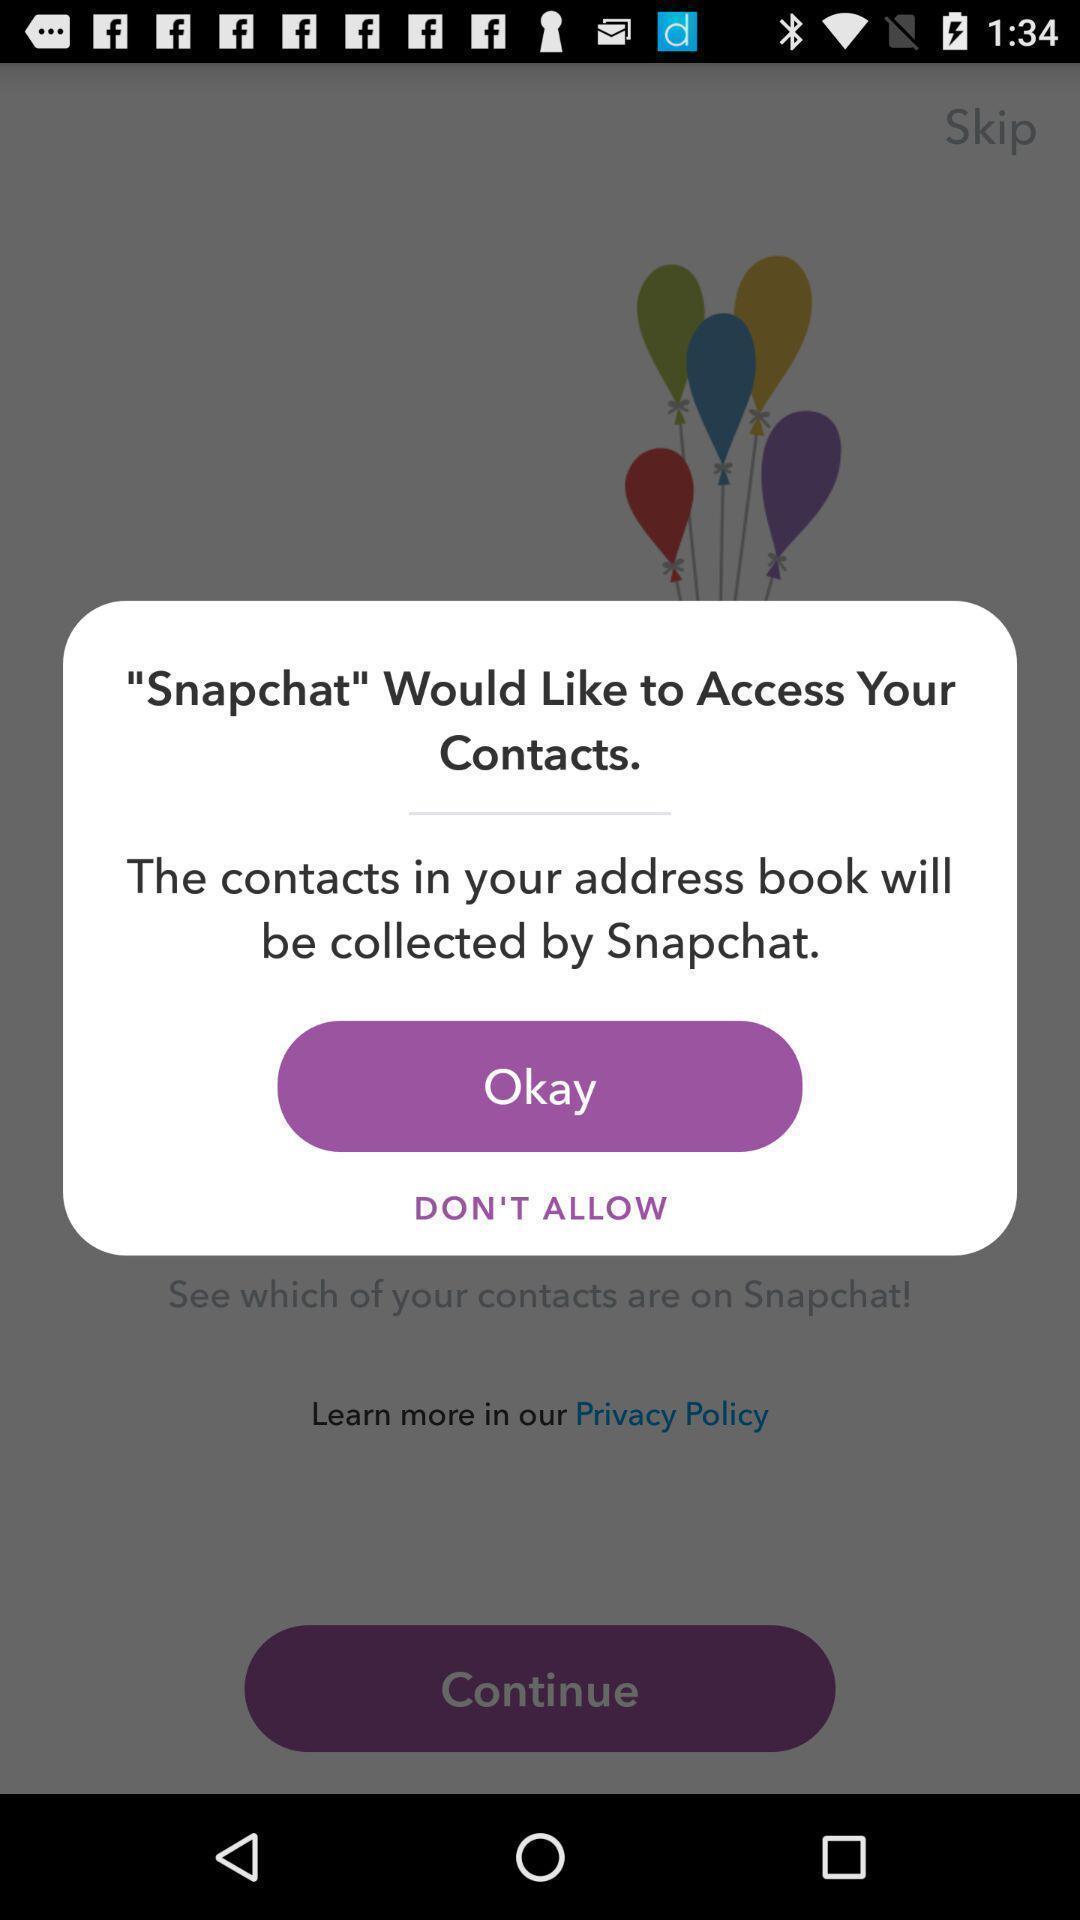Describe this image in words. Pop up to access contacts for application. 